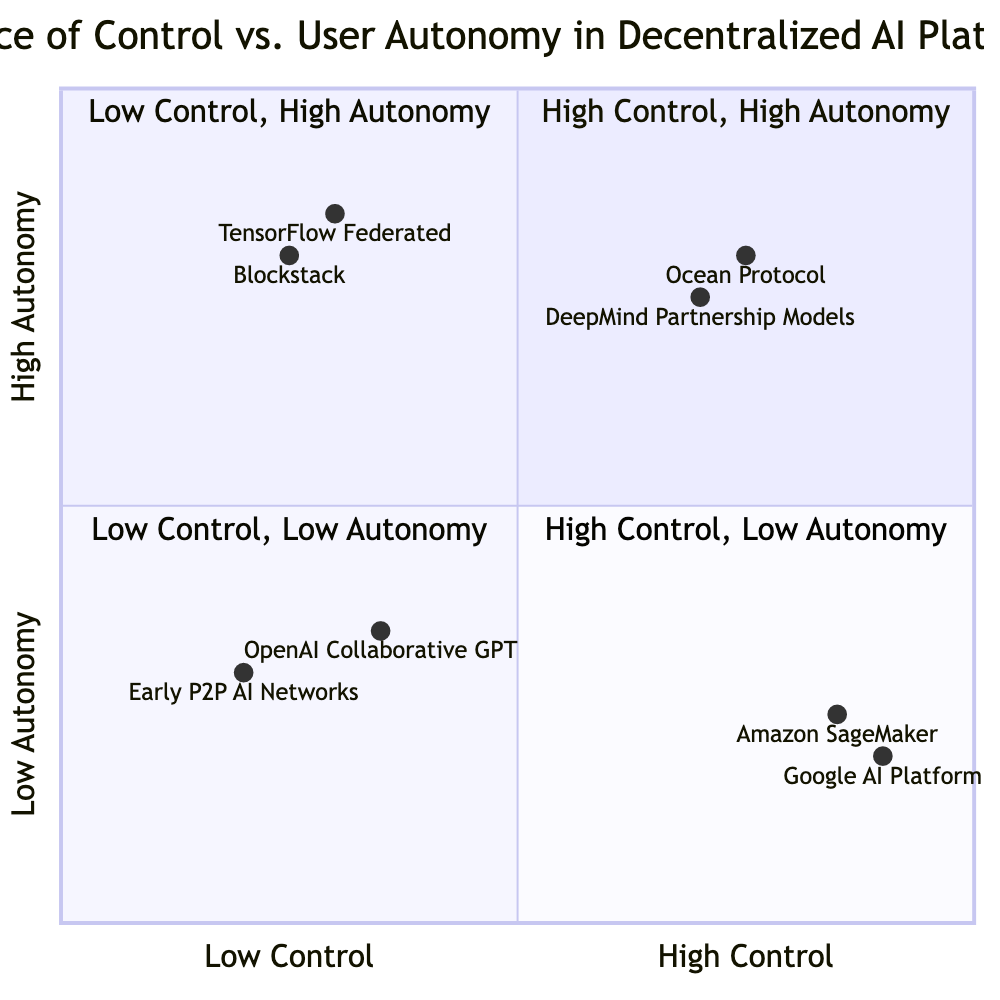What is the y-coordinate of Google AI Platform? The y-coordinate for Google AI Platform is determined from its position in the quadrant, noted as [0.90, 0.20]. The second value indicates the y-coordinate, which is 0.20.
Answer: 0.20 Which platform is located in the Low Control, High Autonomy quadrant? The Low Control, High Autonomy quadrant features platforms that provide significant user autonomy with minimal provider control. From the data, both TensorFlow Federated and Blockstack are examples.
Answer: TensorFlow Federated, Blockstack How many examples are listed in the High Control, High Autonomy quadrant? Referring to the High Control, High Autonomy quadrant, there are two examples provided, which are Ocean Protocol and DeepMind Partnership Models.
Answer: 2 Which platform has the highest control value? To assess control values on the x-axis, one reviews the listed coordinates. Google AI Platform has an x-coordinate of 0.90, which is the highest among all platforms.
Answer: Google AI Platform What is the average autonomy score for the platforms in the Low Control, Low Autonomy quadrant? The platforms in this quadrant, Early P2P AI Networks and OpenAI Collaborative GPT, have y-coordinates of 0.30 and 0.35 respectively. The average is computed as (0.30 + 0.35) / 2 = 0.325.
Answer: 0.325 In which quadrant is Amazon SageMaker placed? Amazon SageMaker is positioned according to its coordinates, which are [0.85, 0.25]. The x-axis value indicates high control, while the y-axis value indicates low autonomy, placing it in the High Control, Low Autonomy quadrant.
Answer: High Control, Low Autonomy What is the lowest autonomy value among the platforms listed? By reviewing the y-coordinates, the lowest autonomy value is found with the Early P2P AI Networks, which has a value of 0.30, the smallest among the provided data points.
Answer: 0.30 Which platform has both high control and high autonomy? In the diagram, the platforms located in the High Control, High Autonomy quadrant according to the examples presented are Ocean Protocol and DeepMind Partnership Models, which both exhibit this characteristic.
Answer: Ocean Protocol, DeepMind Partnership Models 